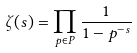<formula> <loc_0><loc_0><loc_500><loc_500>\zeta ( s ) = \prod _ { p \in P } \frac { 1 } { 1 - p ^ { - s } }</formula> 